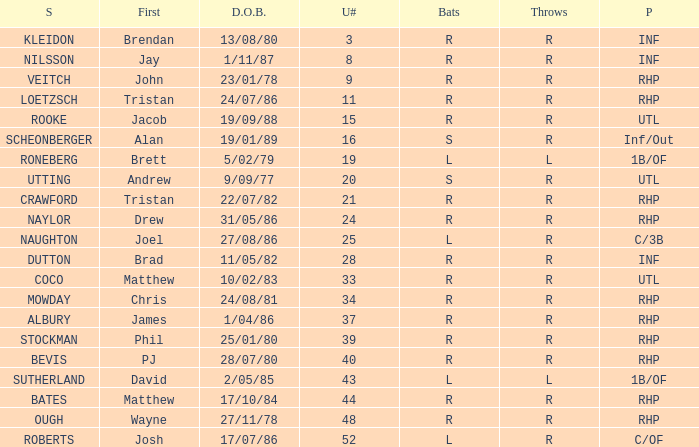Which First has a Uni # larger than 34, and Throws of r, and a Position of rhp, and a Surname of stockman? Phil. 